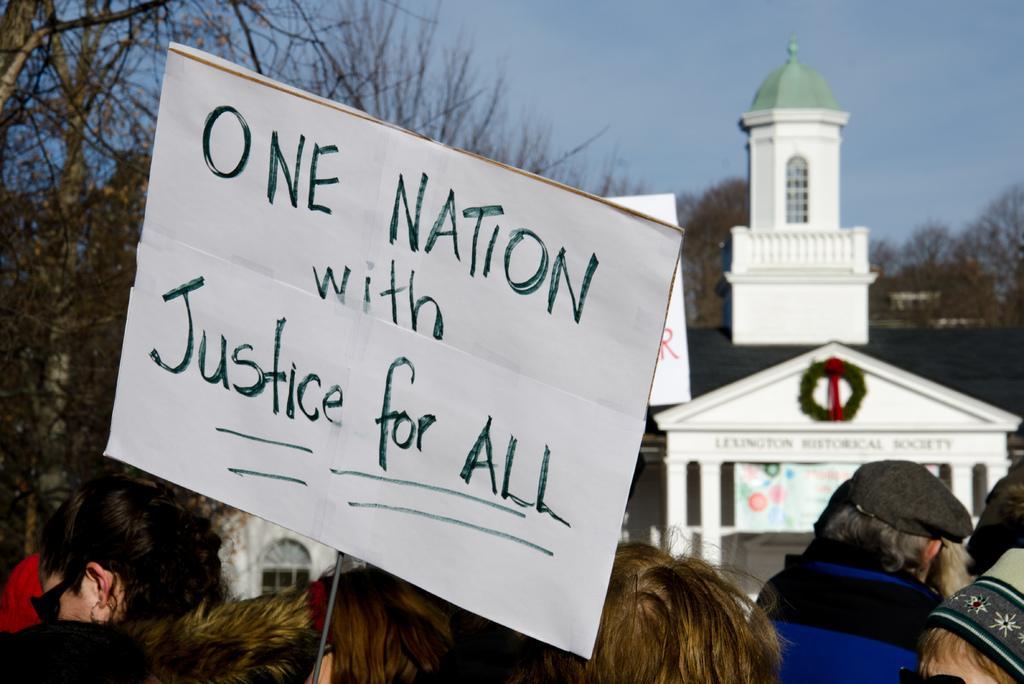Please provide a concise description of this image. In this image we can see one building, some people are standing, one white board with text, some trees, one red object attached to the building, one board with text attached to the pole, some text on the building, one banner with text and images attached to the building. At the top there is the sky. 